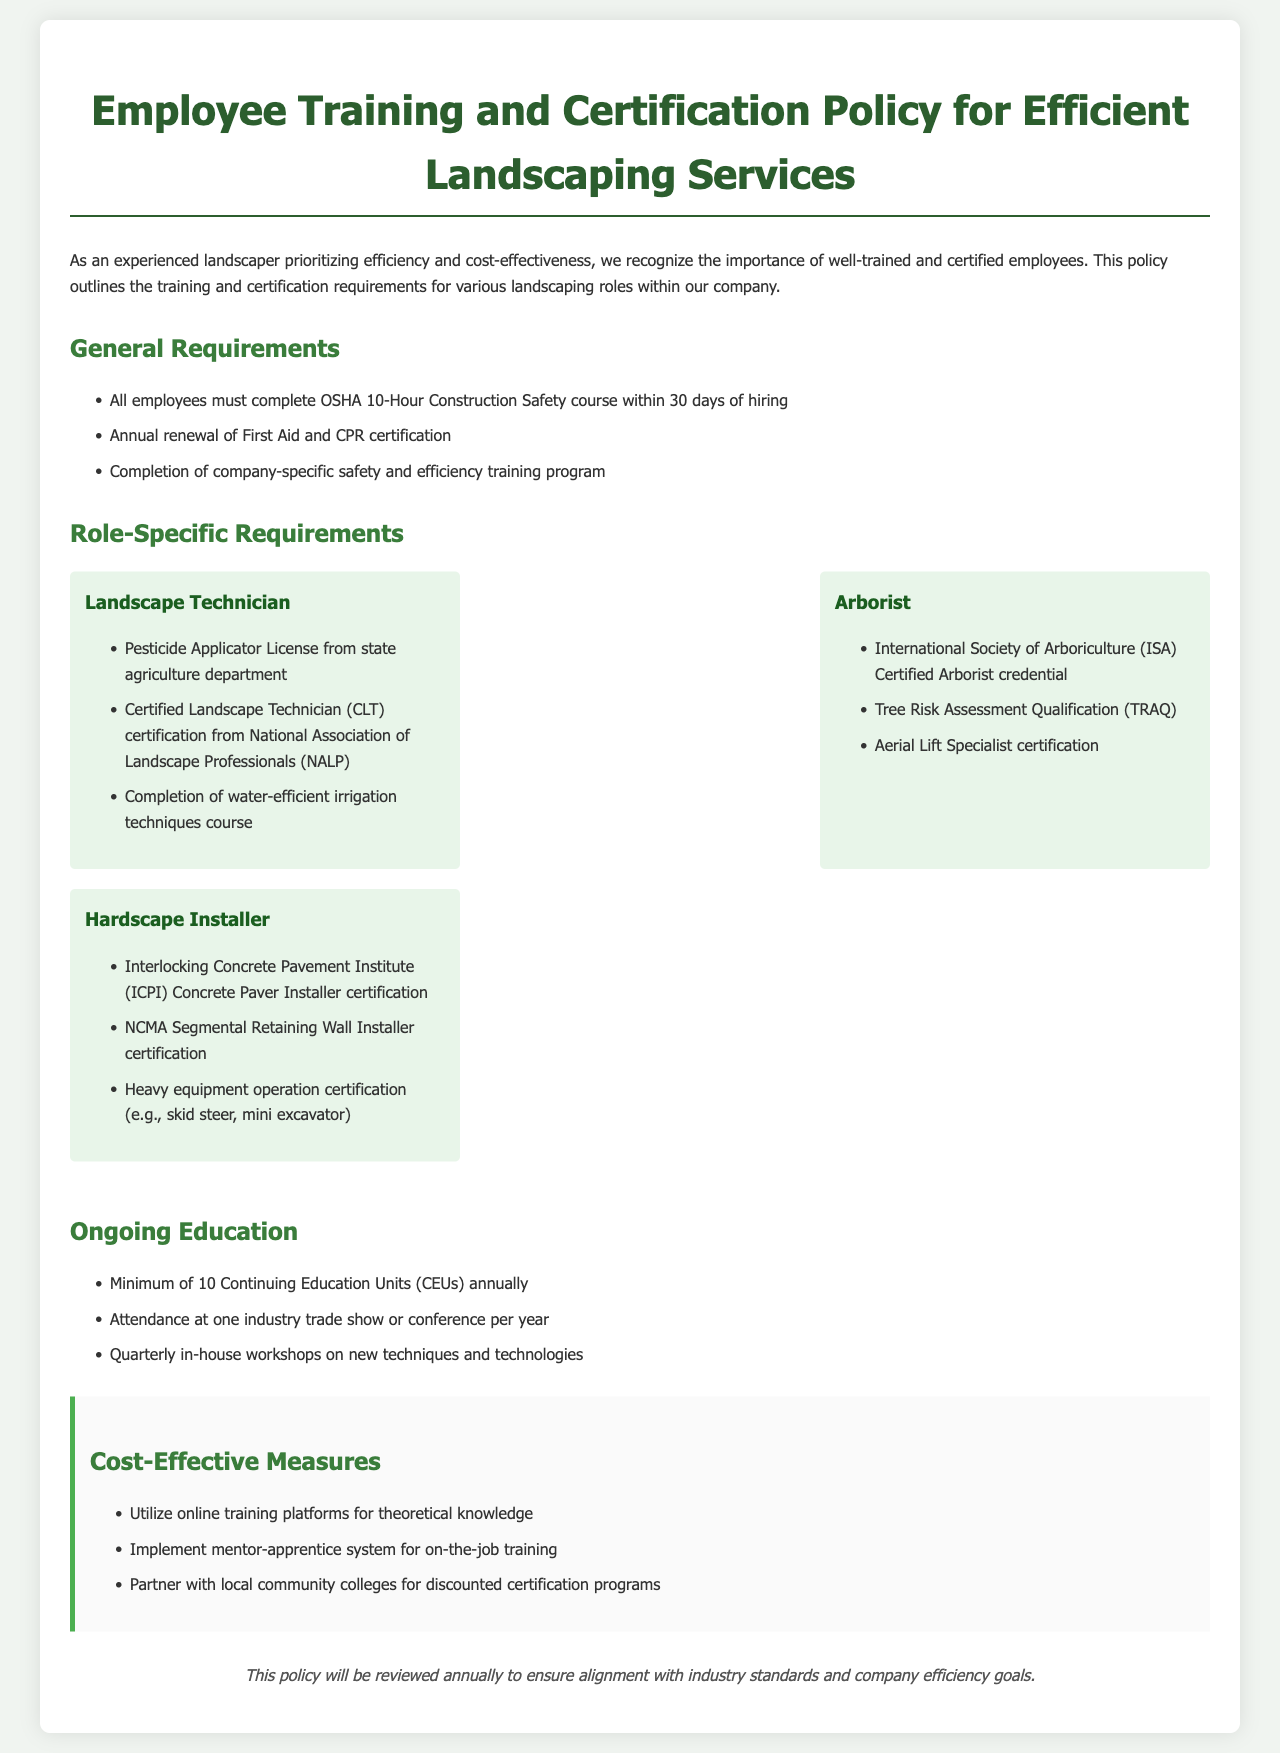What is the OSHA course requirement? The document states that all employees must complete the OSHA 10-Hour Construction Safety course within 30 days of hiring.
Answer: OSHA 10-Hour Construction Safety course How often must First Aid and CPR certification be renewed? According to the document, there is an annual renewal requirement for First Aid and CPR certification.
Answer: Annual What certification is required for a Landscape Technician? The document lists the Certified Landscape Technician (CLT) certification from the National Association of Landscape Professionals (NALP) as a requirement for Landscape Technicians.
Answer: Certified Landscape Technician (CLT) What is the minimum number of Continuing Education Units required annually? The document specifies that a minimum of 10 Continuing Education Units (CEUs) annually is required.
Answer: 10 Which certification is associated with the Arborist role? The International Society of Arboriculture (ISA) Certified Arborist credential is mentioned as a requirement for Arborists in the document.
Answer: ISA Certified Arborist What is one cost-effective measure mentioned in the policy? The document suggests utilizing online training platforms for theoretical knowledge as a cost-effective measure.
Answer: Utilizing online training platforms How frequently must the policy be reviewed? The document states that the policy will be reviewed annually to ensure alignment with industry standards.
Answer: Annually What organization issues the Pesticide Applicator License? The document indicates that the Pesticide Applicator License is issued by the state agriculture department.
Answer: State agriculture department 